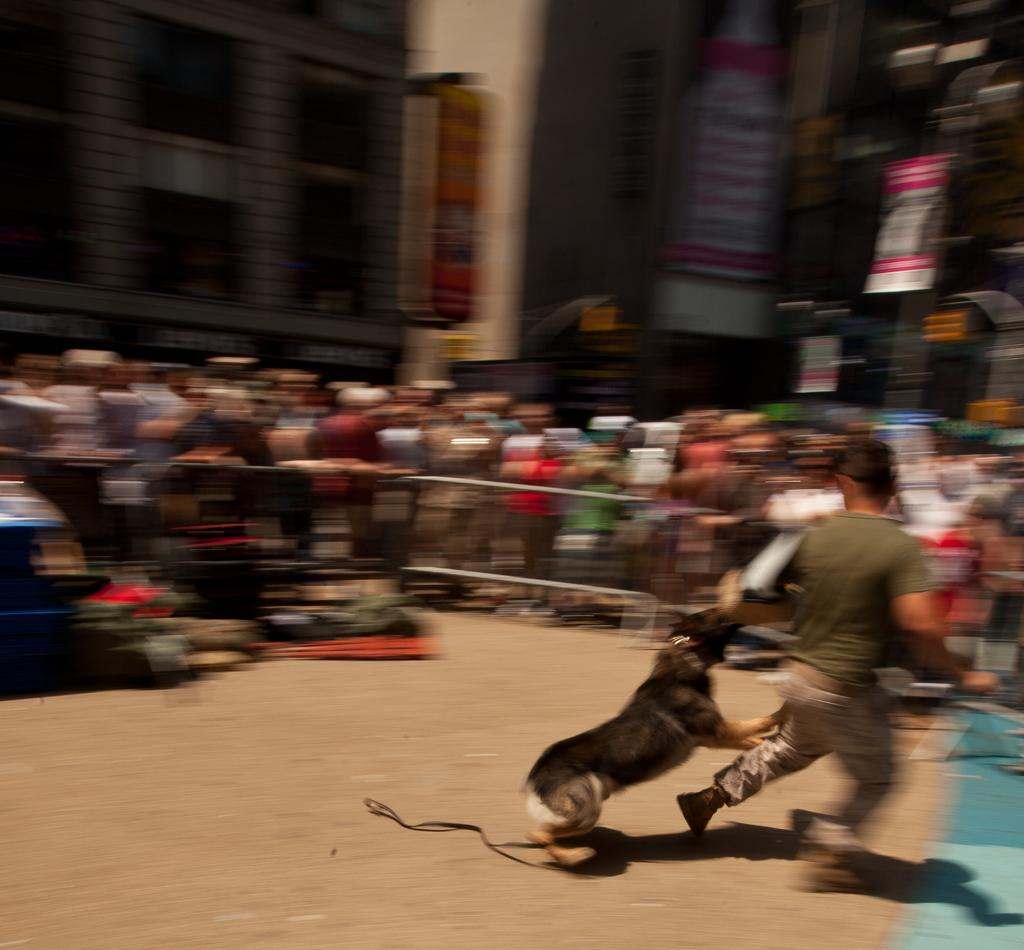What can be observed about the background of the image? The background of the image is blurry. What can be seen hanging in the image? There are banners in the image. What is the main group of people doing in the image? There is a crowd of people in the image. What is the dog in the image doing? The dog is running in the image and chasing a man. What type of lamp is being adjusted by the middle person in the image? There is no lamp present in the image, nor is there a person adjusting anything. 